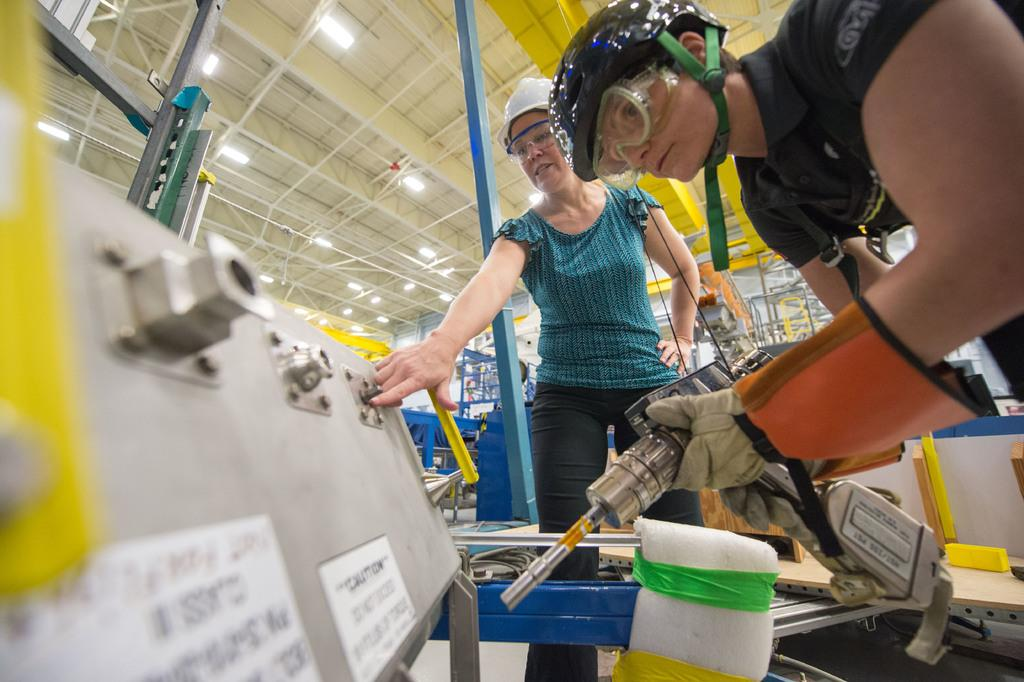How many people are the persons are in the image? There are two persons standing in front of a machine in the image. What is the condition of the roof in the image? There are lights on the roof in the image. Can you describe the objects visible at the back side of the image? Unfortunately, the provided facts do not give any information about the objects visible at the back side of the image. What type of sail can be seen on the machine in the image? There is no sail present on the machine in the image. How many bricks are visible on the roof in the image? There is no information about bricks on the roof in the provided facts. 